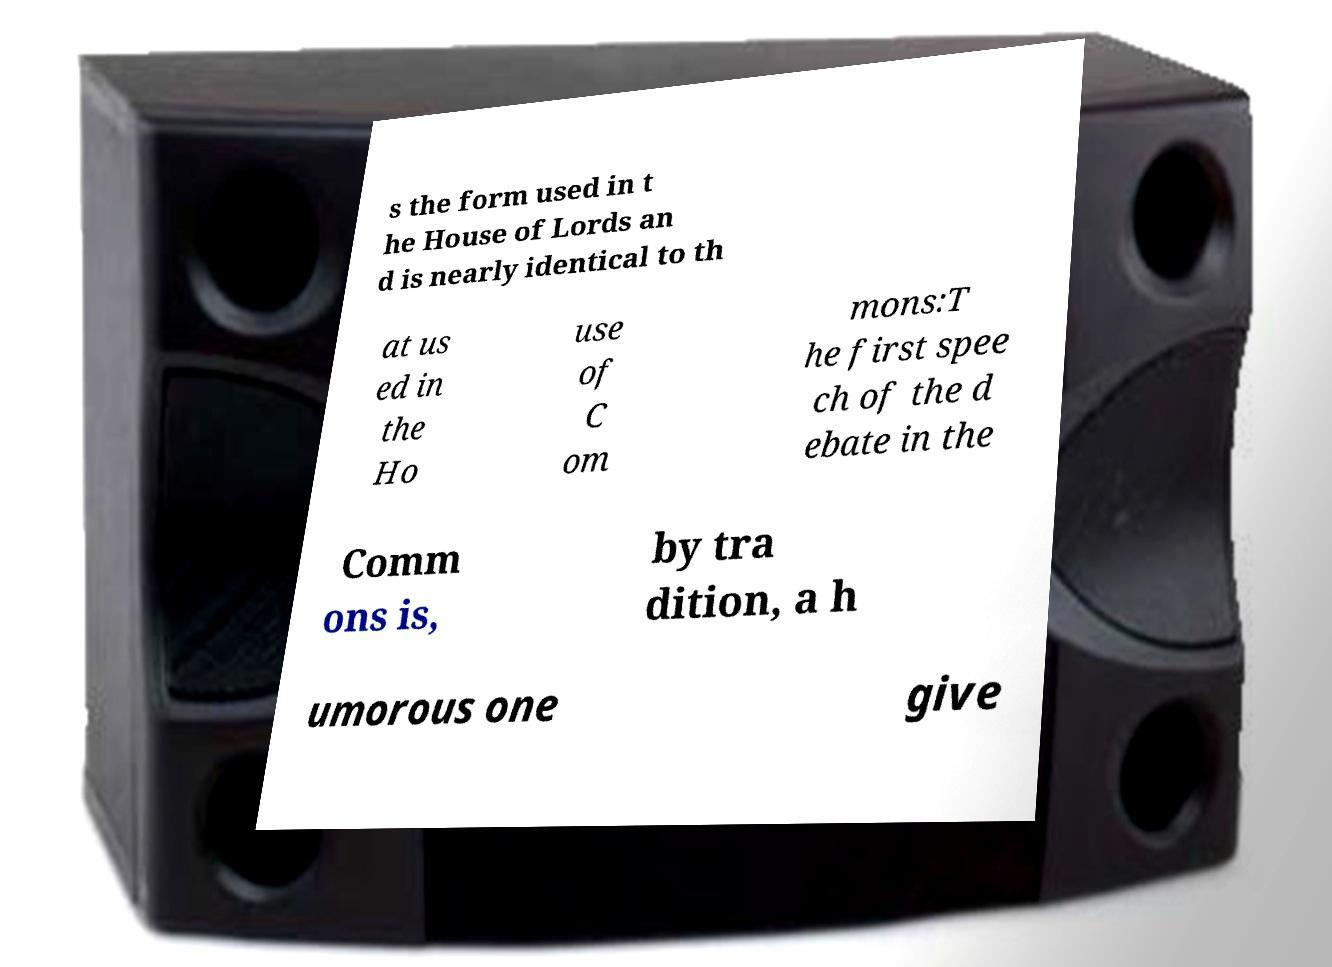Please identify and transcribe the text found in this image. s the form used in t he House of Lords an d is nearly identical to th at us ed in the Ho use of C om mons:T he first spee ch of the d ebate in the Comm ons is, by tra dition, a h umorous one give 